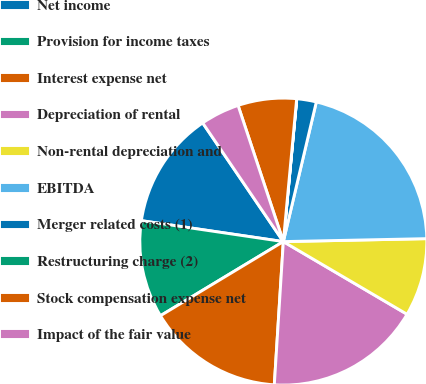Convert chart to OTSL. <chart><loc_0><loc_0><loc_500><loc_500><pie_chart><fcel>Net income<fcel>Provision for income taxes<fcel>Interest expense net<fcel>Depreciation of rental<fcel>Non-rental depreciation and<fcel>EBITDA<fcel>Merger related costs (1)<fcel>Restructuring charge (2)<fcel>Stock compensation expense net<fcel>Impact of the fair value<nl><fcel>13.17%<fcel>10.97%<fcel>15.36%<fcel>17.55%<fcel>8.78%<fcel>20.98%<fcel>2.2%<fcel>0.01%<fcel>6.59%<fcel>4.39%<nl></chart> 